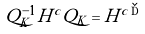<formula> <loc_0><loc_0><loc_500><loc_500>Q ^ { - 1 } _ { K } H ^ { c } Q _ { K } = H ^ { c \, { \dag } }</formula> 